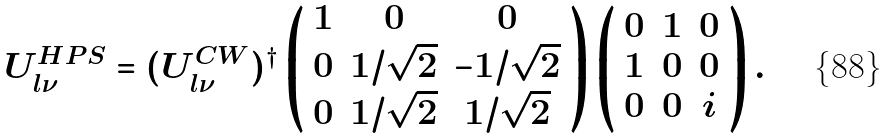<formula> <loc_0><loc_0><loc_500><loc_500>U _ { l \nu } ^ { H P S } = ( U _ { l \nu } ^ { C W } ) ^ { \dagger } \left ( \begin{array} { c c c } 1 & 0 & 0 \\ 0 & 1 / \sqrt { 2 } & - 1 / \sqrt { 2 } \\ 0 & 1 / \sqrt { 2 } & 1 / \sqrt { 2 } \end{array} \right ) \left ( \begin{array} { c c c } 0 & 1 & 0 \\ 1 & 0 & 0 \\ 0 & 0 & i \end{array} \right ) .</formula> 